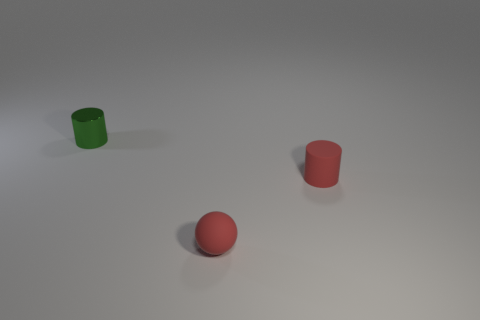What shape is the thing that is the same color as the small rubber ball? cylinder 